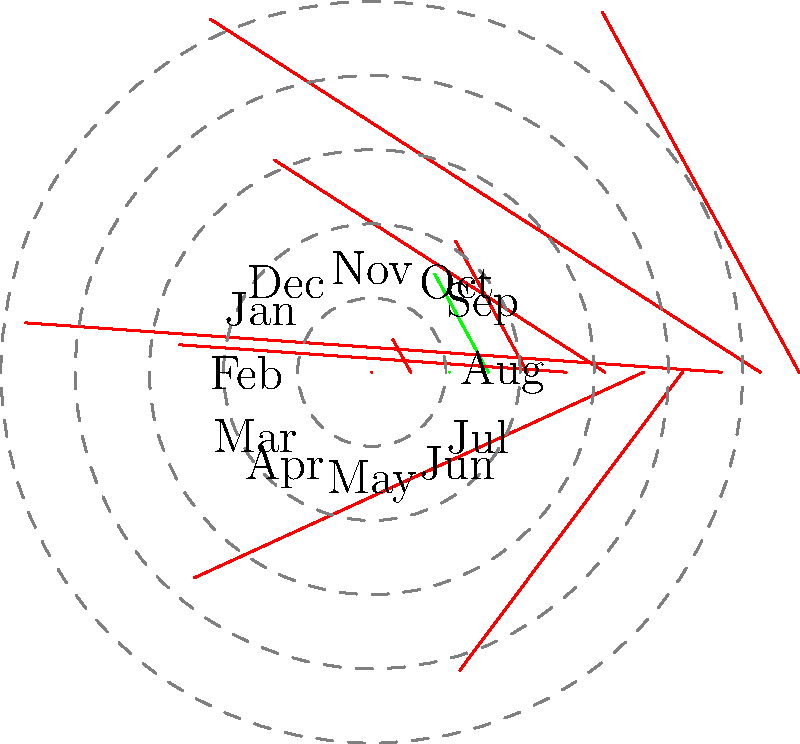In the polar rose diagram representing Hartlepool United's goal difference throughout a season, which month shows the worst goal difference, and what is its value? To answer this question, we need to analyze the polar rose diagram:

1. Each spoke of the diagram represents a month of the season, starting with August at 0° and progressing clockwise.
2. The length of each spoke represents the absolute value of the goal difference.
3. Green spokes indicate positive goal differences, while red spokes indicate negative goal differences.
4. The worst goal difference will be the longest red spoke.

Examining the diagram:
1. August (0°): -2
2. September (30°): -1
3. October (60°): 0
4. November (90°): +1
5. December (120°): -1
6. January (150°): -3
7. February (180°): -2
8. March (210°): -4
9. April (240°): -5
10. May (270°): -3
11. June (300°): -2
12. July (330°): -1

The longest red spoke corresponds to April (240°) with a value of -5. This represents the worst goal difference of the season.
Answer: April, -5 